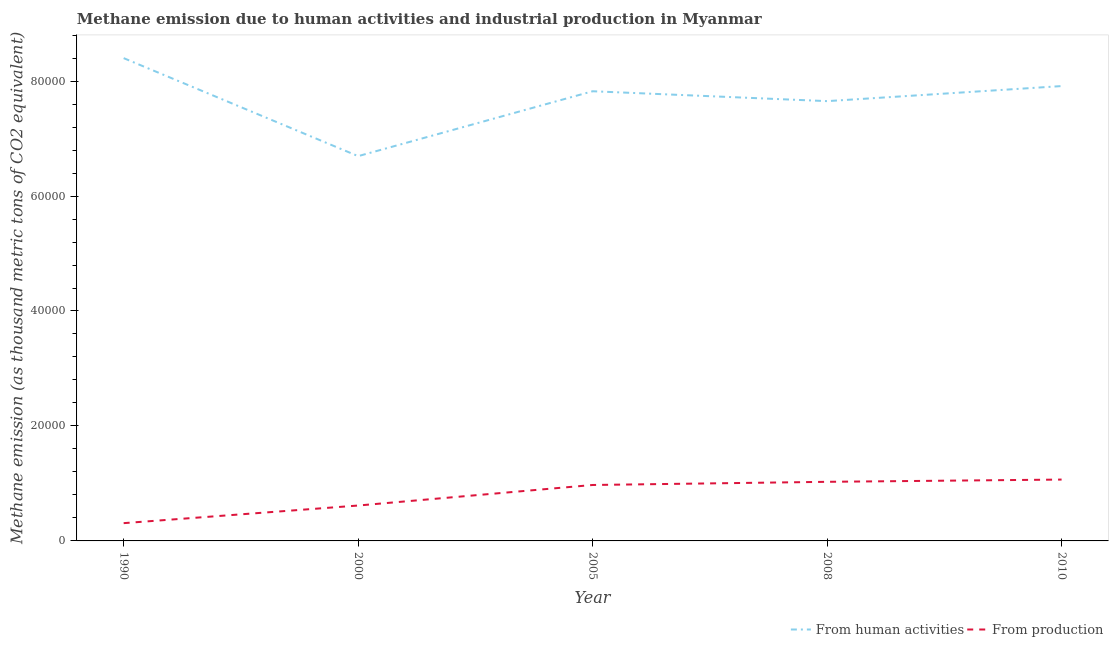How many different coloured lines are there?
Keep it short and to the point. 2. Is the number of lines equal to the number of legend labels?
Provide a succinct answer. Yes. What is the amount of emissions from human activities in 1990?
Your answer should be very brief. 8.40e+04. Across all years, what is the maximum amount of emissions generated from industries?
Your answer should be very brief. 1.07e+04. Across all years, what is the minimum amount of emissions from human activities?
Provide a short and direct response. 6.69e+04. In which year was the amount of emissions from human activities maximum?
Offer a very short reply. 1990. In which year was the amount of emissions generated from industries minimum?
Offer a very short reply. 1990. What is the total amount of emissions generated from industries in the graph?
Provide a succinct answer. 3.99e+04. What is the difference between the amount of emissions generated from industries in 2008 and that in 2010?
Offer a terse response. -390.9. What is the difference between the amount of emissions from human activities in 2000 and the amount of emissions generated from industries in 1990?
Provide a short and direct response. 6.38e+04. What is the average amount of emissions generated from industries per year?
Make the answer very short. 7987.46. In the year 2008, what is the difference between the amount of emissions from human activities and amount of emissions generated from industries?
Make the answer very short. 6.62e+04. In how many years, is the amount of emissions generated from industries greater than 36000 thousand metric tons?
Provide a short and direct response. 0. What is the ratio of the amount of emissions generated from industries in 1990 to that in 2005?
Provide a succinct answer. 0.32. Is the difference between the amount of emissions generated from industries in 2005 and 2008 greater than the difference between the amount of emissions from human activities in 2005 and 2008?
Offer a terse response. No. What is the difference between the highest and the second highest amount of emissions from human activities?
Offer a very short reply. 4861.9. What is the difference between the highest and the lowest amount of emissions generated from industries?
Provide a succinct answer. 7581.7. In how many years, is the amount of emissions generated from industries greater than the average amount of emissions generated from industries taken over all years?
Keep it short and to the point. 3. Is the sum of the amount of emissions from human activities in 2000 and 2005 greater than the maximum amount of emissions generated from industries across all years?
Keep it short and to the point. Yes. Does the amount of emissions generated from industries monotonically increase over the years?
Offer a very short reply. Yes. How many years are there in the graph?
Offer a terse response. 5. What is the difference between two consecutive major ticks on the Y-axis?
Provide a short and direct response. 2.00e+04. Does the graph contain any zero values?
Keep it short and to the point. No. Does the graph contain grids?
Provide a succinct answer. No. Where does the legend appear in the graph?
Make the answer very short. Bottom right. How many legend labels are there?
Provide a succinct answer. 2. What is the title of the graph?
Keep it short and to the point. Methane emission due to human activities and industrial production in Myanmar. What is the label or title of the X-axis?
Ensure brevity in your answer.  Year. What is the label or title of the Y-axis?
Your response must be concise. Methane emission (as thousand metric tons of CO2 equivalent). What is the Methane emission (as thousand metric tons of CO2 equivalent) in From human activities in 1990?
Offer a terse response. 8.40e+04. What is the Methane emission (as thousand metric tons of CO2 equivalent) of From production in 1990?
Your answer should be very brief. 3091.9. What is the Methane emission (as thousand metric tons of CO2 equivalent) of From human activities in 2000?
Your answer should be compact. 6.69e+04. What is the Methane emission (as thousand metric tons of CO2 equivalent) in From production in 2000?
Offer a terse response. 6157.4. What is the Methane emission (as thousand metric tons of CO2 equivalent) of From human activities in 2005?
Your answer should be very brief. 7.82e+04. What is the Methane emission (as thousand metric tons of CO2 equivalent) in From production in 2005?
Offer a very short reply. 9731.7. What is the Methane emission (as thousand metric tons of CO2 equivalent) in From human activities in 2008?
Your response must be concise. 7.65e+04. What is the Methane emission (as thousand metric tons of CO2 equivalent) of From production in 2008?
Give a very brief answer. 1.03e+04. What is the Methane emission (as thousand metric tons of CO2 equivalent) of From human activities in 2010?
Offer a very short reply. 7.91e+04. What is the Methane emission (as thousand metric tons of CO2 equivalent) in From production in 2010?
Provide a succinct answer. 1.07e+04. Across all years, what is the maximum Methane emission (as thousand metric tons of CO2 equivalent) of From human activities?
Your response must be concise. 8.40e+04. Across all years, what is the maximum Methane emission (as thousand metric tons of CO2 equivalent) in From production?
Keep it short and to the point. 1.07e+04. Across all years, what is the minimum Methane emission (as thousand metric tons of CO2 equivalent) in From human activities?
Provide a succinct answer. 6.69e+04. Across all years, what is the minimum Methane emission (as thousand metric tons of CO2 equivalent) in From production?
Provide a short and direct response. 3091.9. What is the total Methane emission (as thousand metric tons of CO2 equivalent) in From human activities in the graph?
Offer a terse response. 3.85e+05. What is the total Methane emission (as thousand metric tons of CO2 equivalent) in From production in the graph?
Your response must be concise. 3.99e+04. What is the difference between the Methane emission (as thousand metric tons of CO2 equivalent) in From human activities in 1990 and that in 2000?
Your answer should be very brief. 1.71e+04. What is the difference between the Methane emission (as thousand metric tons of CO2 equivalent) of From production in 1990 and that in 2000?
Provide a short and direct response. -3065.5. What is the difference between the Methane emission (as thousand metric tons of CO2 equivalent) in From human activities in 1990 and that in 2005?
Make the answer very short. 5762.1. What is the difference between the Methane emission (as thousand metric tons of CO2 equivalent) in From production in 1990 and that in 2005?
Ensure brevity in your answer.  -6639.8. What is the difference between the Methane emission (as thousand metric tons of CO2 equivalent) in From human activities in 1990 and that in 2008?
Keep it short and to the point. 7482.7. What is the difference between the Methane emission (as thousand metric tons of CO2 equivalent) of From production in 1990 and that in 2008?
Your answer should be very brief. -7190.8. What is the difference between the Methane emission (as thousand metric tons of CO2 equivalent) in From human activities in 1990 and that in 2010?
Provide a succinct answer. 4861.9. What is the difference between the Methane emission (as thousand metric tons of CO2 equivalent) in From production in 1990 and that in 2010?
Your answer should be compact. -7581.7. What is the difference between the Methane emission (as thousand metric tons of CO2 equivalent) in From human activities in 2000 and that in 2005?
Ensure brevity in your answer.  -1.13e+04. What is the difference between the Methane emission (as thousand metric tons of CO2 equivalent) in From production in 2000 and that in 2005?
Provide a short and direct response. -3574.3. What is the difference between the Methane emission (as thousand metric tons of CO2 equivalent) of From human activities in 2000 and that in 2008?
Provide a short and direct response. -9568.6. What is the difference between the Methane emission (as thousand metric tons of CO2 equivalent) in From production in 2000 and that in 2008?
Offer a terse response. -4125.3. What is the difference between the Methane emission (as thousand metric tons of CO2 equivalent) in From human activities in 2000 and that in 2010?
Ensure brevity in your answer.  -1.22e+04. What is the difference between the Methane emission (as thousand metric tons of CO2 equivalent) in From production in 2000 and that in 2010?
Ensure brevity in your answer.  -4516.2. What is the difference between the Methane emission (as thousand metric tons of CO2 equivalent) of From human activities in 2005 and that in 2008?
Give a very brief answer. 1720.6. What is the difference between the Methane emission (as thousand metric tons of CO2 equivalent) in From production in 2005 and that in 2008?
Offer a very short reply. -551. What is the difference between the Methane emission (as thousand metric tons of CO2 equivalent) of From human activities in 2005 and that in 2010?
Offer a very short reply. -900.2. What is the difference between the Methane emission (as thousand metric tons of CO2 equivalent) in From production in 2005 and that in 2010?
Provide a succinct answer. -941.9. What is the difference between the Methane emission (as thousand metric tons of CO2 equivalent) in From human activities in 2008 and that in 2010?
Provide a succinct answer. -2620.8. What is the difference between the Methane emission (as thousand metric tons of CO2 equivalent) of From production in 2008 and that in 2010?
Give a very brief answer. -390.9. What is the difference between the Methane emission (as thousand metric tons of CO2 equivalent) in From human activities in 1990 and the Methane emission (as thousand metric tons of CO2 equivalent) in From production in 2000?
Give a very brief answer. 7.78e+04. What is the difference between the Methane emission (as thousand metric tons of CO2 equivalent) of From human activities in 1990 and the Methane emission (as thousand metric tons of CO2 equivalent) of From production in 2005?
Keep it short and to the point. 7.43e+04. What is the difference between the Methane emission (as thousand metric tons of CO2 equivalent) in From human activities in 1990 and the Methane emission (as thousand metric tons of CO2 equivalent) in From production in 2008?
Provide a succinct answer. 7.37e+04. What is the difference between the Methane emission (as thousand metric tons of CO2 equivalent) of From human activities in 1990 and the Methane emission (as thousand metric tons of CO2 equivalent) of From production in 2010?
Offer a terse response. 7.33e+04. What is the difference between the Methane emission (as thousand metric tons of CO2 equivalent) of From human activities in 2000 and the Methane emission (as thousand metric tons of CO2 equivalent) of From production in 2005?
Offer a very short reply. 5.72e+04. What is the difference between the Methane emission (as thousand metric tons of CO2 equivalent) in From human activities in 2000 and the Methane emission (as thousand metric tons of CO2 equivalent) in From production in 2008?
Provide a succinct answer. 5.67e+04. What is the difference between the Methane emission (as thousand metric tons of CO2 equivalent) of From human activities in 2000 and the Methane emission (as thousand metric tons of CO2 equivalent) of From production in 2010?
Ensure brevity in your answer.  5.63e+04. What is the difference between the Methane emission (as thousand metric tons of CO2 equivalent) in From human activities in 2005 and the Methane emission (as thousand metric tons of CO2 equivalent) in From production in 2008?
Your response must be concise. 6.79e+04. What is the difference between the Methane emission (as thousand metric tons of CO2 equivalent) in From human activities in 2005 and the Methane emission (as thousand metric tons of CO2 equivalent) in From production in 2010?
Your response must be concise. 6.76e+04. What is the difference between the Methane emission (as thousand metric tons of CO2 equivalent) in From human activities in 2008 and the Methane emission (as thousand metric tons of CO2 equivalent) in From production in 2010?
Give a very brief answer. 6.58e+04. What is the average Methane emission (as thousand metric tons of CO2 equivalent) of From human activities per year?
Offer a terse response. 7.70e+04. What is the average Methane emission (as thousand metric tons of CO2 equivalent) of From production per year?
Make the answer very short. 7987.46. In the year 1990, what is the difference between the Methane emission (as thousand metric tons of CO2 equivalent) of From human activities and Methane emission (as thousand metric tons of CO2 equivalent) of From production?
Offer a very short reply. 8.09e+04. In the year 2000, what is the difference between the Methane emission (as thousand metric tons of CO2 equivalent) in From human activities and Methane emission (as thousand metric tons of CO2 equivalent) in From production?
Offer a terse response. 6.08e+04. In the year 2005, what is the difference between the Methane emission (as thousand metric tons of CO2 equivalent) in From human activities and Methane emission (as thousand metric tons of CO2 equivalent) in From production?
Give a very brief answer. 6.85e+04. In the year 2008, what is the difference between the Methane emission (as thousand metric tons of CO2 equivalent) in From human activities and Methane emission (as thousand metric tons of CO2 equivalent) in From production?
Provide a succinct answer. 6.62e+04. In the year 2010, what is the difference between the Methane emission (as thousand metric tons of CO2 equivalent) of From human activities and Methane emission (as thousand metric tons of CO2 equivalent) of From production?
Offer a very short reply. 6.85e+04. What is the ratio of the Methane emission (as thousand metric tons of CO2 equivalent) of From human activities in 1990 to that in 2000?
Provide a succinct answer. 1.25. What is the ratio of the Methane emission (as thousand metric tons of CO2 equivalent) in From production in 1990 to that in 2000?
Give a very brief answer. 0.5. What is the ratio of the Methane emission (as thousand metric tons of CO2 equivalent) in From human activities in 1990 to that in 2005?
Your answer should be compact. 1.07. What is the ratio of the Methane emission (as thousand metric tons of CO2 equivalent) in From production in 1990 to that in 2005?
Provide a succinct answer. 0.32. What is the ratio of the Methane emission (as thousand metric tons of CO2 equivalent) of From human activities in 1990 to that in 2008?
Your response must be concise. 1.1. What is the ratio of the Methane emission (as thousand metric tons of CO2 equivalent) of From production in 1990 to that in 2008?
Your answer should be compact. 0.3. What is the ratio of the Methane emission (as thousand metric tons of CO2 equivalent) of From human activities in 1990 to that in 2010?
Offer a very short reply. 1.06. What is the ratio of the Methane emission (as thousand metric tons of CO2 equivalent) of From production in 1990 to that in 2010?
Ensure brevity in your answer.  0.29. What is the ratio of the Methane emission (as thousand metric tons of CO2 equivalent) of From human activities in 2000 to that in 2005?
Your answer should be very brief. 0.86. What is the ratio of the Methane emission (as thousand metric tons of CO2 equivalent) of From production in 2000 to that in 2005?
Provide a succinct answer. 0.63. What is the ratio of the Methane emission (as thousand metric tons of CO2 equivalent) of From human activities in 2000 to that in 2008?
Give a very brief answer. 0.87. What is the ratio of the Methane emission (as thousand metric tons of CO2 equivalent) of From production in 2000 to that in 2008?
Give a very brief answer. 0.6. What is the ratio of the Methane emission (as thousand metric tons of CO2 equivalent) in From human activities in 2000 to that in 2010?
Your answer should be very brief. 0.85. What is the ratio of the Methane emission (as thousand metric tons of CO2 equivalent) of From production in 2000 to that in 2010?
Your answer should be very brief. 0.58. What is the ratio of the Methane emission (as thousand metric tons of CO2 equivalent) of From human activities in 2005 to that in 2008?
Offer a very short reply. 1.02. What is the ratio of the Methane emission (as thousand metric tons of CO2 equivalent) of From production in 2005 to that in 2008?
Make the answer very short. 0.95. What is the ratio of the Methane emission (as thousand metric tons of CO2 equivalent) in From production in 2005 to that in 2010?
Provide a succinct answer. 0.91. What is the ratio of the Methane emission (as thousand metric tons of CO2 equivalent) of From human activities in 2008 to that in 2010?
Your answer should be very brief. 0.97. What is the ratio of the Methane emission (as thousand metric tons of CO2 equivalent) in From production in 2008 to that in 2010?
Ensure brevity in your answer.  0.96. What is the difference between the highest and the second highest Methane emission (as thousand metric tons of CO2 equivalent) in From human activities?
Your answer should be very brief. 4861.9. What is the difference between the highest and the second highest Methane emission (as thousand metric tons of CO2 equivalent) of From production?
Offer a very short reply. 390.9. What is the difference between the highest and the lowest Methane emission (as thousand metric tons of CO2 equivalent) in From human activities?
Offer a very short reply. 1.71e+04. What is the difference between the highest and the lowest Methane emission (as thousand metric tons of CO2 equivalent) of From production?
Your answer should be compact. 7581.7. 